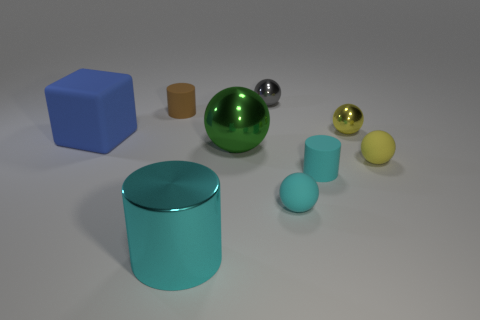Is there a blue matte cube that has the same size as the yellow metallic thing? Yes, there is a blue matte cube in the image that appears to have the same size as the yellow metallic sphere. 